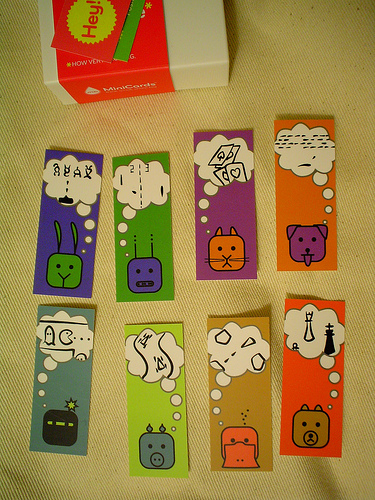<image>
Is there a card one on the card two? No. The card one is not positioned on the card two. They may be near each other, but the card one is not supported by or resting on top of the card two. 